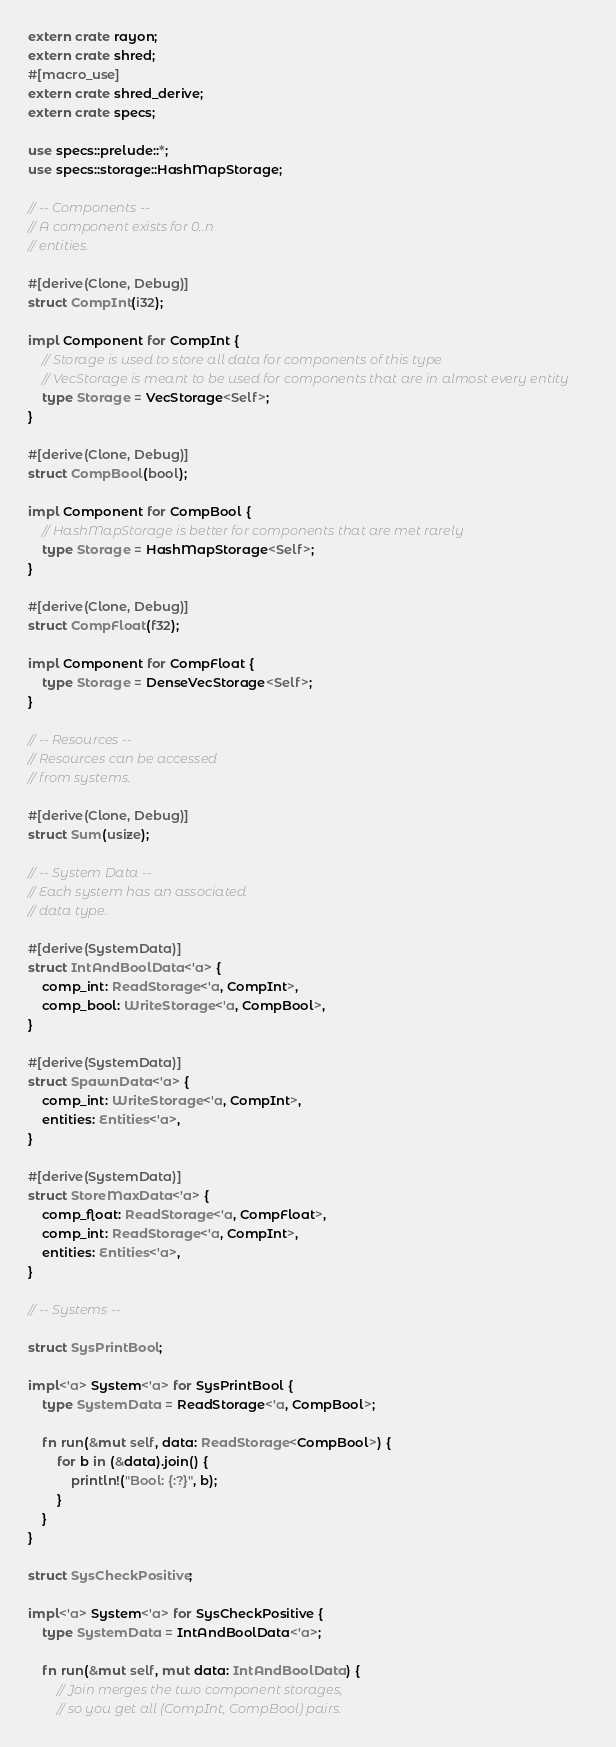<code> <loc_0><loc_0><loc_500><loc_500><_Rust_>extern crate rayon;
extern crate shred;
#[macro_use]
extern crate shred_derive;
extern crate specs;

use specs::prelude::*;
use specs::storage::HashMapStorage;

// -- Components --
// A component exists for 0..n
// entities.

#[derive(Clone, Debug)]
struct CompInt(i32);

impl Component for CompInt {
    // Storage is used to store all data for components of this type
    // VecStorage is meant to be used for components that are in almost every entity
    type Storage = VecStorage<Self>;
}

#[derive(Clone, Debug)]
struct CompBool(bool);

impl Component for CompBool {
    // HashMapStorage is better for components that are met rarely
    type Storage = HashMapStorage<Self>;
}

#[derive(Clone, Debug)]
struct CompFloat(f32);

impl Component for CompFloat {
    type Storage = DenseVecStorage<Self>;
}

// -- Resources --
// Resources can be accessed
// from systems.

#[derive(Clone, Debug)]
struct Sum(usize);

// -- System Data --
// Each system has an associated
// data type.

#[derive(SystemData)]
struct IntAndBoolData<'a> {
    comp_int: ReadStorage<'a, CompInt>,
    comp_bool: WriteStorage<'a, CompBool>,
}

#[derive(SystemData)]
struct SpawnData<'a> {
    comp_int: WriteStorage<'a, CompInt>,
    entities: Entities<'a>,
}

#[derive(SystemData)]
struct StoreMaxData<'a> {
    comp_float: ReadStorage<'a, CompFloat>,
    comp_int: ReadStorage<'a, CompInt>,
    entities: Entities<'a>,
}

// -- Systems --

struct SysPrintBool;

impl<'a> System<'a> for SysPrintBool {
    type SystemData = ReadStorage<'a, CompBool>;

    fn run(&mut self, data: ReadStorage<CompBool>) {
        for b in (&data).join() {
            println!("Bool: {:?}", b);
        }
    }
}

struct SysCheckPositive;

impl<'a> System<'a> for SysCheckPositive {
    type SystemData = IntAndBoolData<'a>;

    fn run(&mut self, mut data: IntAndBoolData) {
        // Join merges the two component storages,
        // so you get all (CompInt, CompBool) pairs.</code> 